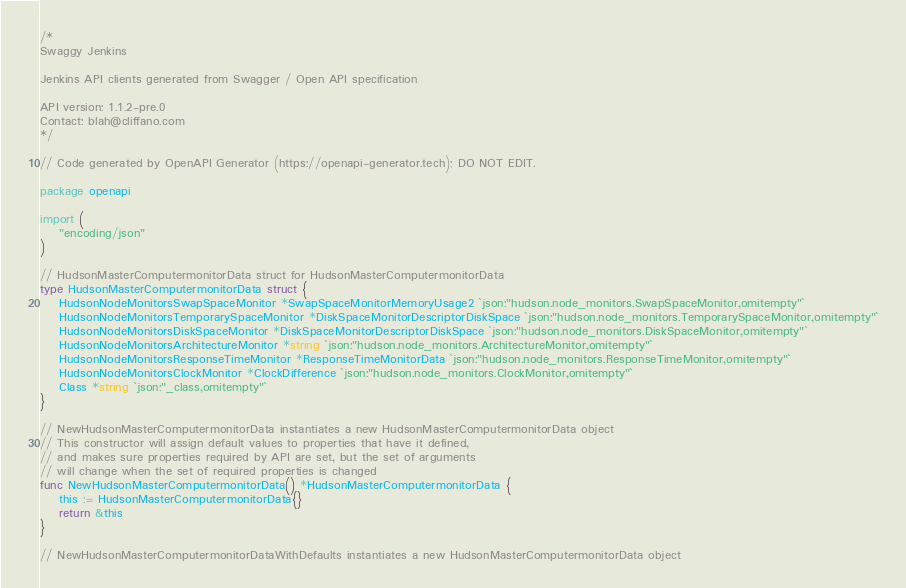<code> <loc_0><loc_0><loc_500><loc_500><_Go_>/*
Swaggy Jenkins

Jenkins API clients generated from Swagger / Open API specification

API version: 1.1.2-pre.0
Contact: blah@cliffano.com
*/

// Code generated by OpenAPI Generator (https://openapi-generator.tech); DO NOT EDIT.

package openapi

import (
	"encoding/json"
)

// HudsonMasterComputermonitorData struct for HudsonMasterComputermonitorData
type HudsonMasterComputermonitorData struct {
	HudsonNodeMonitorsSwapSpaceMonitor *SwapSpaceMonitorMemoryUsage2 `json:"hudson.node_monitors.SwapSpaceMonitor,omitempty"`
	HudsonNodeMonitorsTemporarySpaceMonitor *DiskSpaceMonitorDescriptorDiskSpace `json:"hudson.node_monitors.TemporarySpaceMonitor,omitempty"`
	HudsonNodeMonitorsDiskSpaceMonitor *DiskSpaceMonitorDescriptorDiskSpace `json:"hudson.node_monitors.DiskSpaceMonitor,omitempty"`
	HudsonNodeMonitorsArchitectureMonitor *string `json:"hudson.node_monitors.ArchitectureMonitor,omitempty"`
	HudsonNodeMonitorsResponseTimeMonitor *ResponseTimeMonitorData `json:"hudson.node_monitors.ResponseTimeMonitor,omitempty"`
	HudsonNodeMonitorsClockMonitor *ClockDifference `json:"hudson.node_monitors.ClockMonitor,omitempty"`
	Class *string `json:"_class,omitempty"`
}

// NewHudsonMasterComputermonitorData instantiates a new HudsonMasterComputermonitorData object
// This constructor will assign default values to properties that have it defined,
// and makes sure properties required by API are set, but the set of arguments
// will change when the set of required properties is changed
func NewHudsonMasterComputermonitorData() *HudsonMasterComputermonitorData {
	this := HudsonMasterComputermonitorData{}
	return &this
}

// NewHudsonMasterComputermonitorDataWithDefaults instantiates a new HudsonMasterComputermonitorData object</code> 